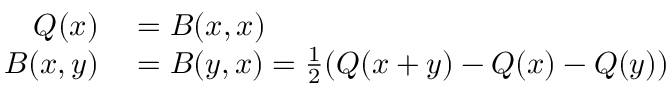<formula> <loc_0><loc_0><loc_500><loc_500>\begin{array} { r l } { Q ( x ) } & = B ( x , x ) } \\ { B ( x , y ) } & = B ( y , x ) = { \frac { 1 } { 2 } } ( Q ( x + y ) - Q ( x ) - Q ( y ) ) } \end{array}</formula> 